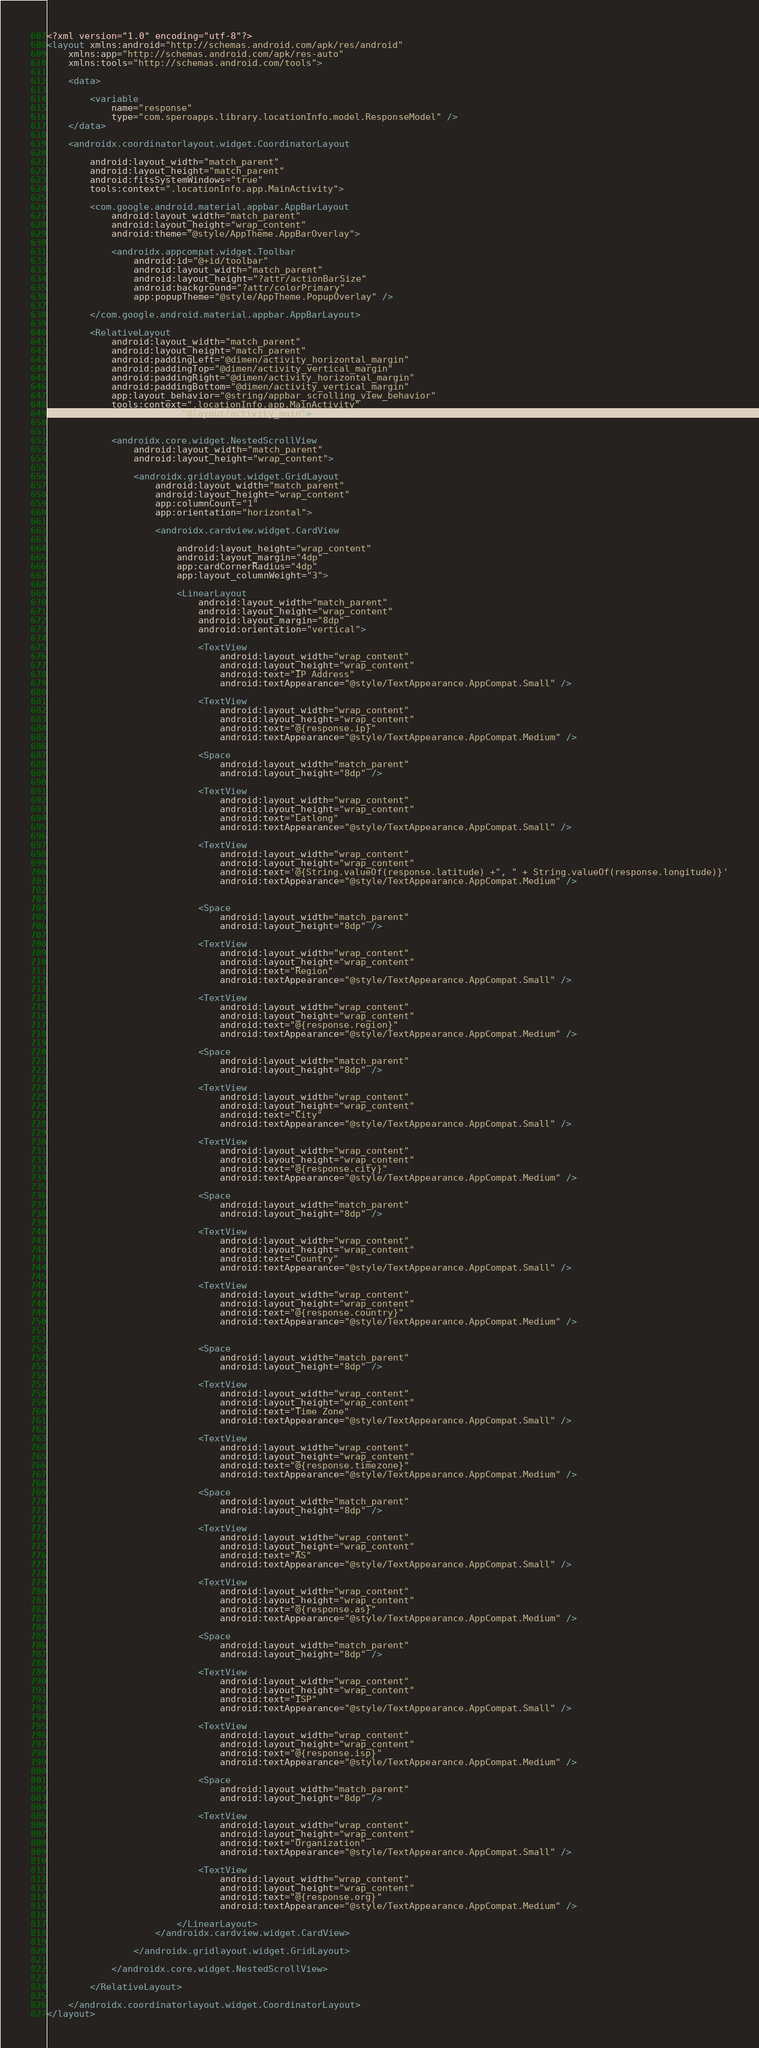Convert code to text. <code><loc_0><loc_0><loc_500><loc_500><_XML_><?xml version="1.0" encoding="utf-8"?>
<layout xmlns:android="http://schemas.android.com/apk/res/android"
    xmlns:app="http://schemas.android.com/apk/res-auto"
    xmlns:tools="http://schemas.android.com/tools">

    <data>

        <variable
            name="response"
            type="com.speroapps.library.locationInfo.model.ResponseModel" />
    </data>

    <androidx.coordinatorlayout.widget.CoordinatorLayout

        android:layout_width="match_parent"
        android:layout_height="match_parent"
        android:fitsSystemWindows="true"
        tools:context=".locationInfo.app.MainActivity">

        <com.google.android.material.appbar.AppBarLayout
            android:layout_width="match_parent"
            android:layout_height="wrap_content"
            android:theme="@style/AppTheme.AppBarOverlay">

            <androidx.appcompat.widget.Toolbar
                android:id="@+id/toolbar"
                android:layout_width="match_parent"
                android:layout_height="?attr/actionBarSize"
                android:background="?attr/colorPrimary"
                app:popupTheme="@style/AppTheme.PopupOverlay" />

        </com.google.android.material.appbar.AppBarLayout>

        <RelativeLayout
            android:layout_width="match_parent"
            android:layout_height="match_parent"
            android:paddingLeft="@dimen/activity_horizontal_margin"
            android:paddingTop="@dimen/activity_vertical_margin"
            android:paddingRight="@dimen/activity_horizontal_margin"
            android:paddingBottom="@dimen/activity_vertical_margin"
            app:layout_behavior="@string/appbar_scrolling_view_behavior"
            tools:context=".locationInfo.app.MainActivity"
            tools:showIn="@layout/activity_main">


            <androidx.core.widget.NestedScrollView
                android:layout_width="match_parent"
                android:layout_height="wrap_content">

                <androidx.gridlayout.widget.GridLayout
                    android:layout_width="match_parent"
                    android:layout_height="wrap_content"
                    app:columnCount="1"
                    app:orientation="horizontal">

                    <androidx.cardview.widget.CardView

                        android:layout_height="wrap_content"
                        android:layout_margin="4dp"
                        app:cardCornerRadius="4dp"
                        app:layout_columnWeight="3">

                        <LinearLayout
                            android:layout_width="match_parent"
                            android:layout_height="wrap_content"
                            android:layout_margin="8dp"
                            android:orientation="vertical">

                            <TextView
                                android:layout_width="wrap_content"
                                android:layout_height="wrap_content"
                                android:text="IP Address"
                                android:textAppearance="@style/TextAppearance.AppCompat.Small" />

                            <TextView
                                android:layout_width="wrap_content"
                                android:layout_height="wrap_content"
                                android:text="@{response.ip}"
                                android:textAppearance="@style/TextAppearance.AppCompat.Medium" />

                            <Space
                                android:layout_width="match_parent"
                                android:layout_height="8dp" />

                            <TextView
                                android:layout_width="wrap_content"
                                android:layout_height="wrap_content"
                                android:text="Latlong"
                                android:textAppearance="@style/TextAppearance.AppCompat.Small" />

                            <TextView
                                android:layout_width="wrap_content"
                                android:layout_height="wrap_content"
                                android:text='@{String.valueOf(response.latitude) +", " + String.valueOf(response.longitude)}'
                                android:textAppearance="@style/TextAppearance.AppCompat.Medium" />


                            <Space
                                android:layout_width="match_parent"
                                android:layout_height="8dp" />

                            <TextView
                                android:layout_width="wrap_content"
                                android:layout_height="wrap_content"
                                android:text="Region"
                                android:textAppearance="@style/TextAppearance.AppCompat.Small" />

                            <TextView
                                android:layout_width="wrap_content"
                                android:layout_height="wrap_content"
                                android:text="@{response.region}"
                                android:textAppearance="@style/TextAppearance.AppCompat.Medium" />

                            <Space
                                android:layout_width="match_parent"
                                android:layout_height="8dp" />

                            <TextView
                                android:layout_width="wrap_content"
                                android:layout_height="wrap_content"
                                android:text="City"
                                android:textAppearance="@style/TextAppearance.AppCompat.Small" />

                            <TextView
                                android:layout_width="wrap_content"
                                android:layout_height="wrap_content"
                                android:text="@{response.city}"
                                android:textAppearance="@style/TextAppearance.AppCompat.Medium" />

                            <Space
                                android:layout_width="match_parent"
                                android:layout_height="8dp" />

                            <TextView
                                android:layout_width="wrap_content"
                                android:layout_height="wrap_content"
                                android:text="Country"
                                android:textAppearance="@style/TextAppearance.AppCompat.Small" />

                            <TextView
                                android:layout_width="wrap_content"
                                android:layout_height="wrap_content"
                                android:text="@{response.country}"
                                android:textAppearance="@style/TextAppearance.AppCompat.Medium" />


                            <Space
                                android:layout_width="match_parent"
                                android:layout_height="8dp" />

                            <TextView
                                android:layout_width="wrap_content"
                                android:layout_height="wrap_content"
                                android:text="Time Zone"
                                android:textAppearance="@style/TextAppearance.AppCompat.Small" />

                            <TextView
                                android:layout_width="wrap_content"
                                android:layout_height="wrap_content"
                                android:text="@{response.timezone}"
                                android:textAppearance="@style/TextAppearance.AppCompat.Medium" />

                            <Space
                                android:layout_width="match_parent"
                                android:layout_height="8dp" />

                            <TextView
                                android:layout_width="wrap_content"
                                android:layout_height="wrap_content"
                                android:text="AS"
                                android:textAppearance="@style/TextAppearance.AppCompat.Small" />

                            <TextView
                                android:layout_width="wrap_content"
                                android:layout_height="wrap_content"
                                android:text="@{response.as}"
                                android:textAppearance="@style/TextAppearance.AppCompat.Medium" />

                            <Space
                                android:layout_width="match_parent"
                                android:layout_height="8dp" />

                            <TextView
                                android:layout_width="wrap_content"
                                android:layout_height="wrap_content"
                                android:text="ISP"
                                android:textAppearance="@style/TextAppearance.AppCompat.Small" />

                            <TextView
                                android:layout_width="wrap_content"
                                android:layout_height="wrap_content"
                                android:text="@{response.isp}"
                                android:textAppearance="@style/TextAppearance.AppCompat.Medium" />

                            <Space
                                android:layout_width="match_parent"
                                android:layout_height="8dp" />

                            <TextView
                                android:layout_width="wrap_content"
                                android:layout_height="wrap_content"
                                android:text="Organization"
                                android:textAppearance="@style/TextAppearance.AppCompat.Small" />

                            <TextView
                                android:layout_width="wrap_content"
                                android:layout_height="wrap_content"
                                android:text="@{response.org}"
                                android:textAppearance="@style/TextAppearance.AppCompat.Medium" />

                        </LinearLayout>
                    </androidx.cardview.widget.CardView>

                </androidx.gridlayout.widget.GridLayout>

            </androidx.core.widget.NestedScrollView>

        </RelativeLayout>

    </androidx.coordinatorlayout.widget.CoordinatorLayout>
</layout>
</code> 